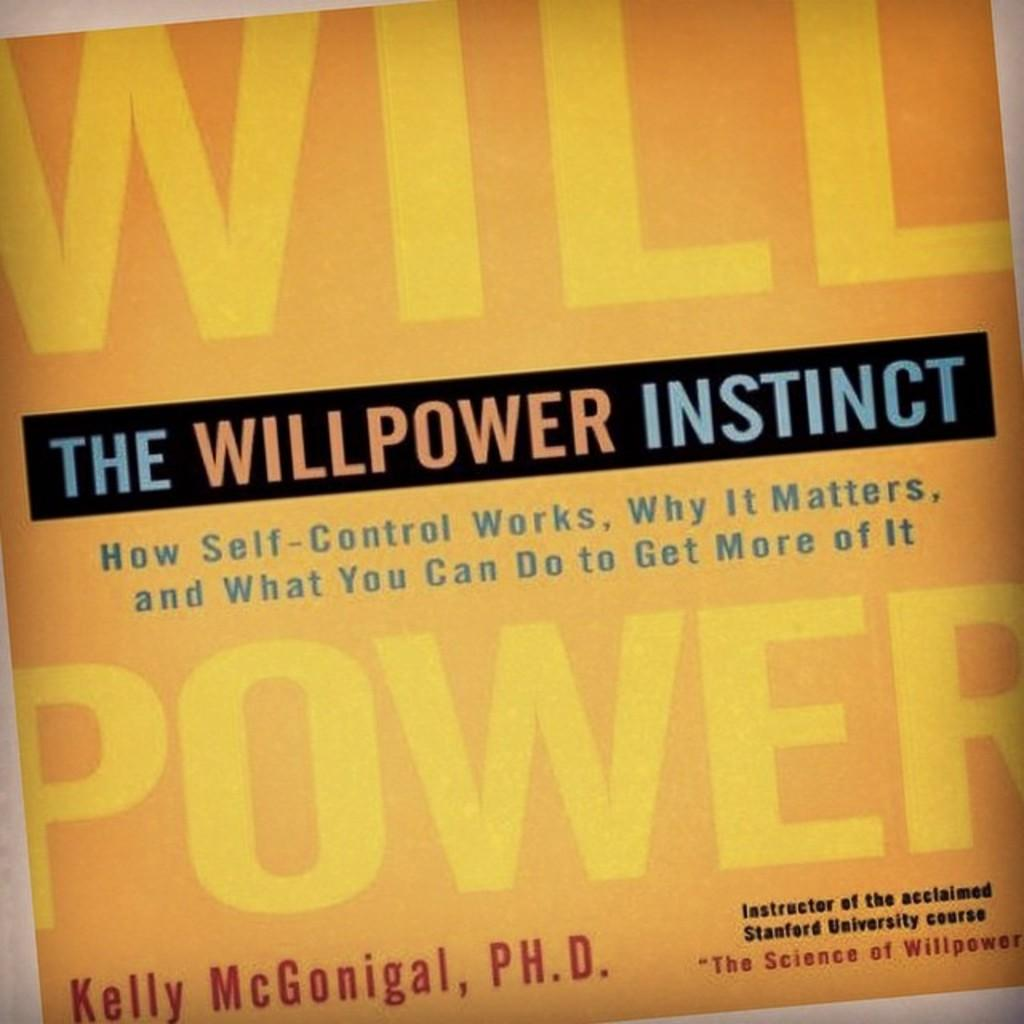<image>
Create a compact narrative representing the image presented. The book shown is written by Kelly McGonigal who has a PH.D. 